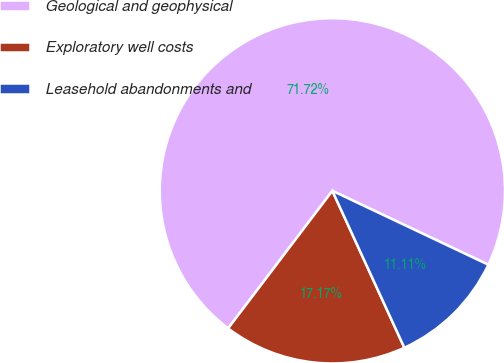Convert chart. <chart><loc_0><loc_0><loc_500><loc_500><pie_chart><fcel>Geological and geophysical<fcel>Exploratory well costs<fcel>Leasehold abandonments and<nl><fcel>71.72%<fcel>17.17%<fcel>11.11%<nl></chart> 